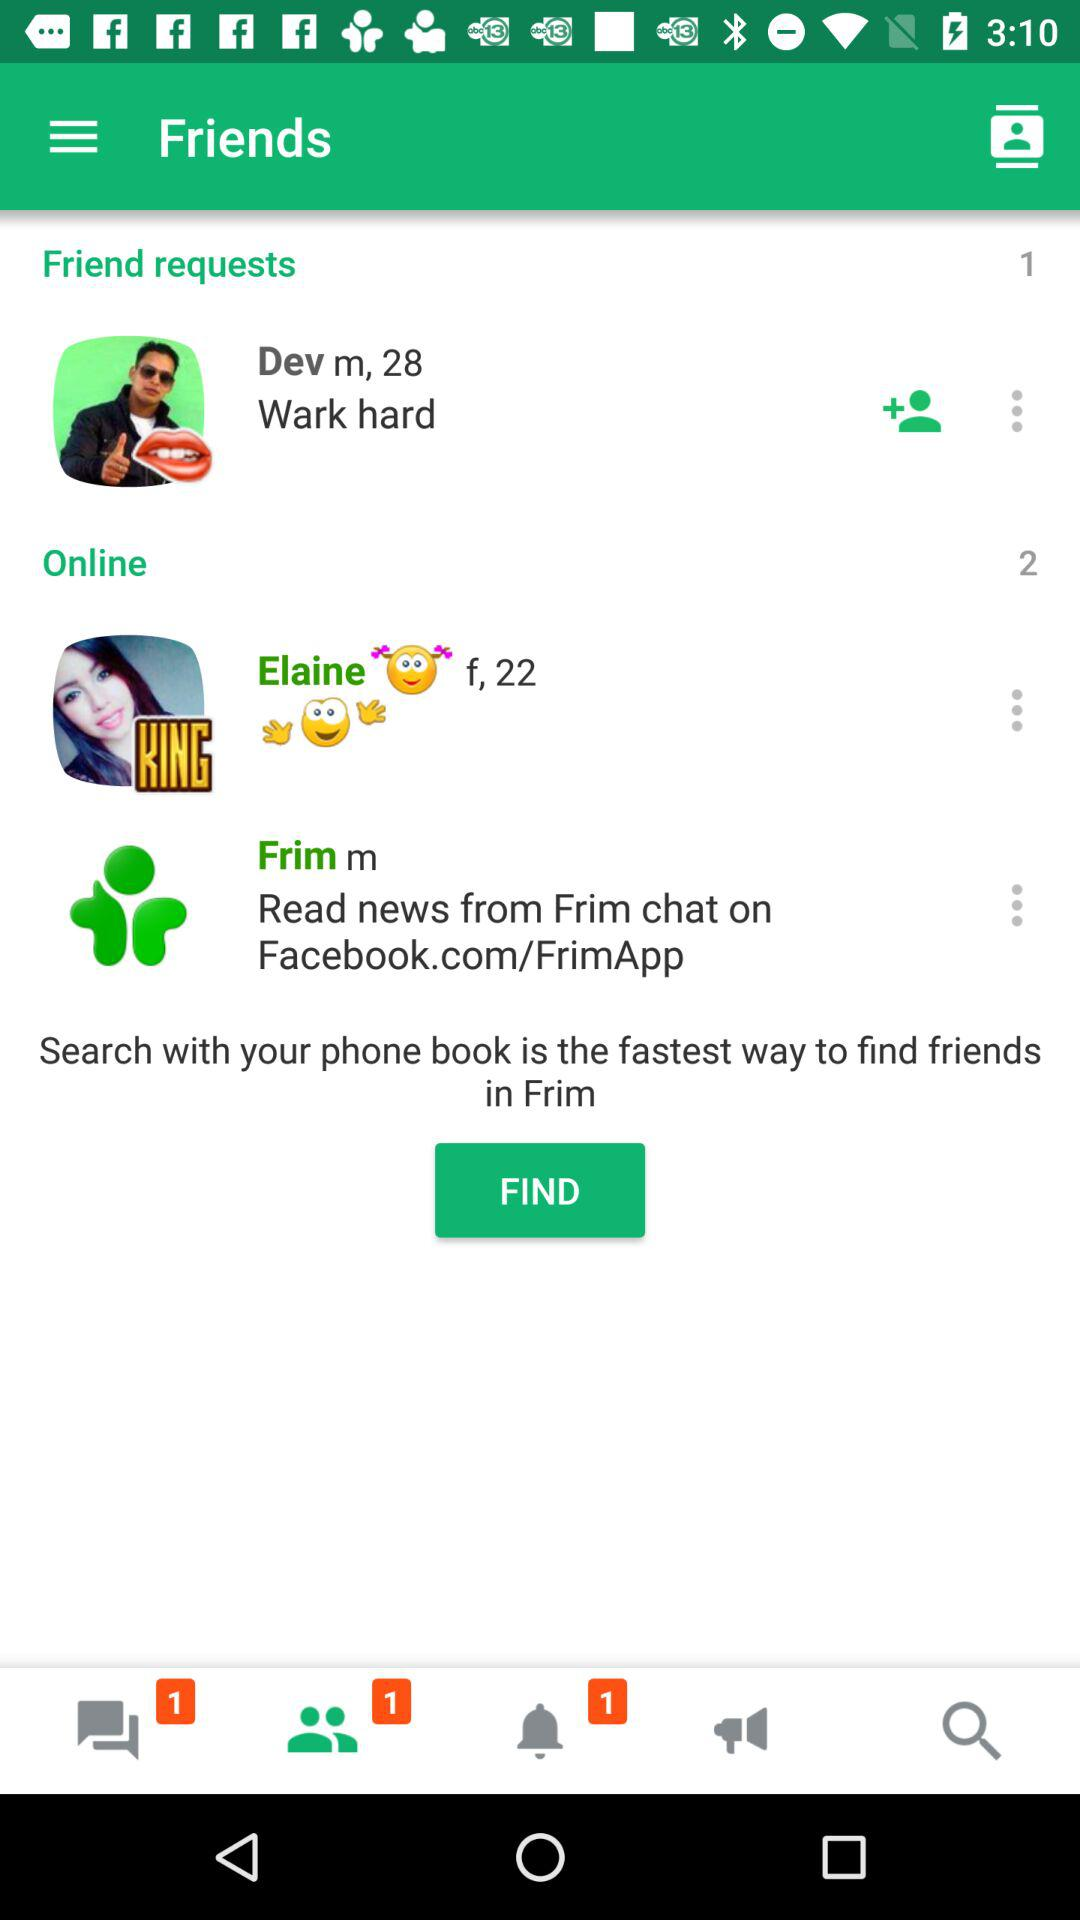How many friend requests are there? There is 1 friend request. 